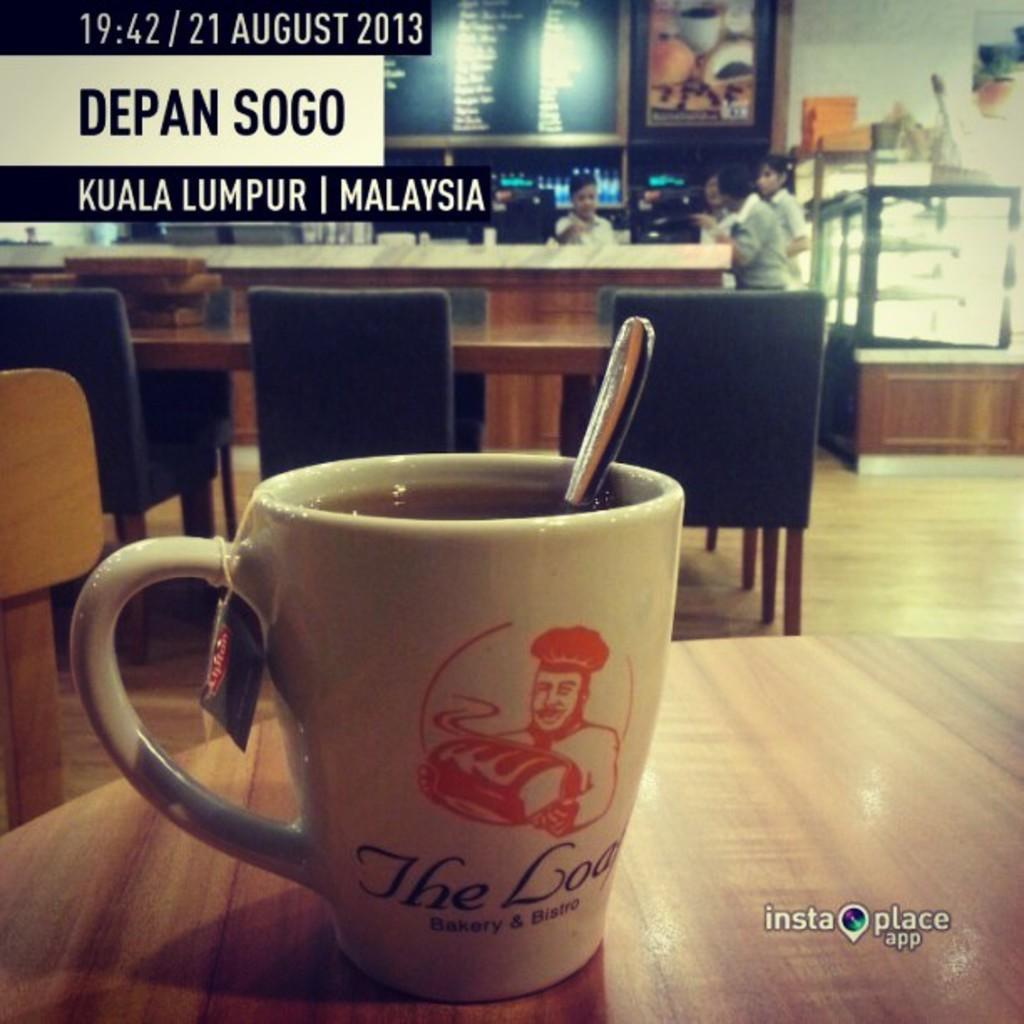What piece of furniture is present in the image? There is a table in the image. What is on the table? There is a cup on the table. What is behind the first table? There is another table behind the first table. What is around the second table? There are chairs around the second table. What is happening near the desk? There are people standing near the desk. What type of tray is being used by the people standing near the van in the image? There is no van or tray present in the image; it only features tables, chairs, and people standing near a desk. 